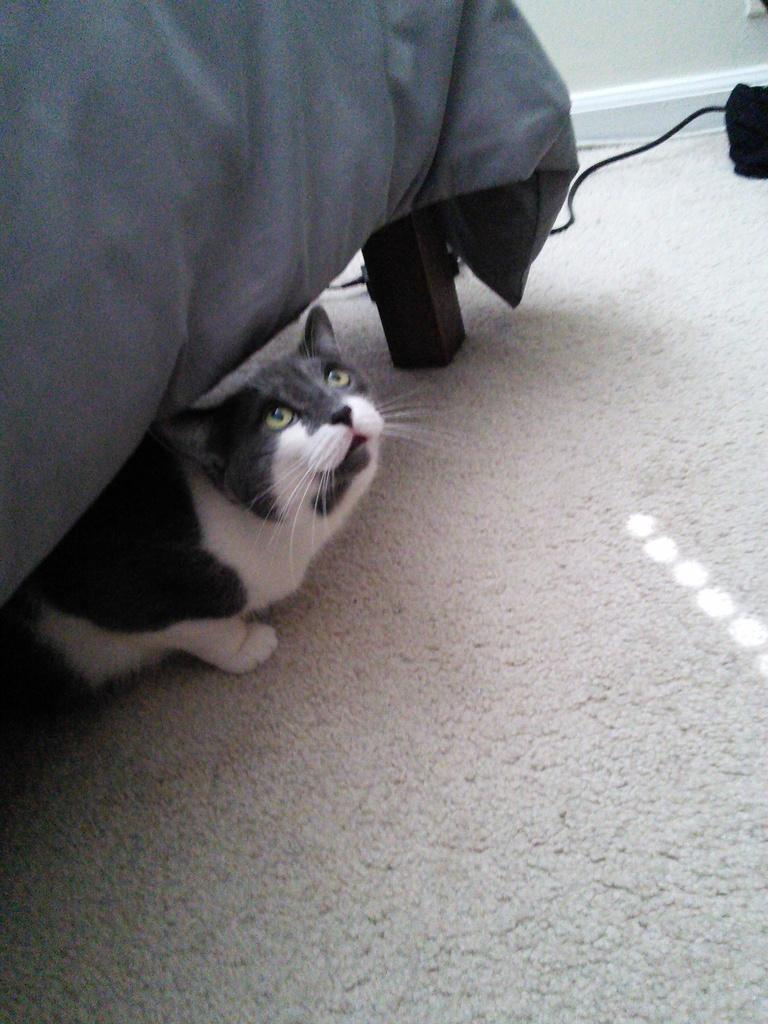Where is the cat located in the image? The cat is under the bed in the image. What can be seen at the back of the image? There is an object at the back of the image. What type of structure is present in the image? There is a wall in the image. What is at the bottom of the image? There is a mat at the bottom of the image. How is the bed covered in the image? The bed is covered with a grey cloth. What is the income of the person in the image? There is no person present in the image, so it is not possible to determine their income. 